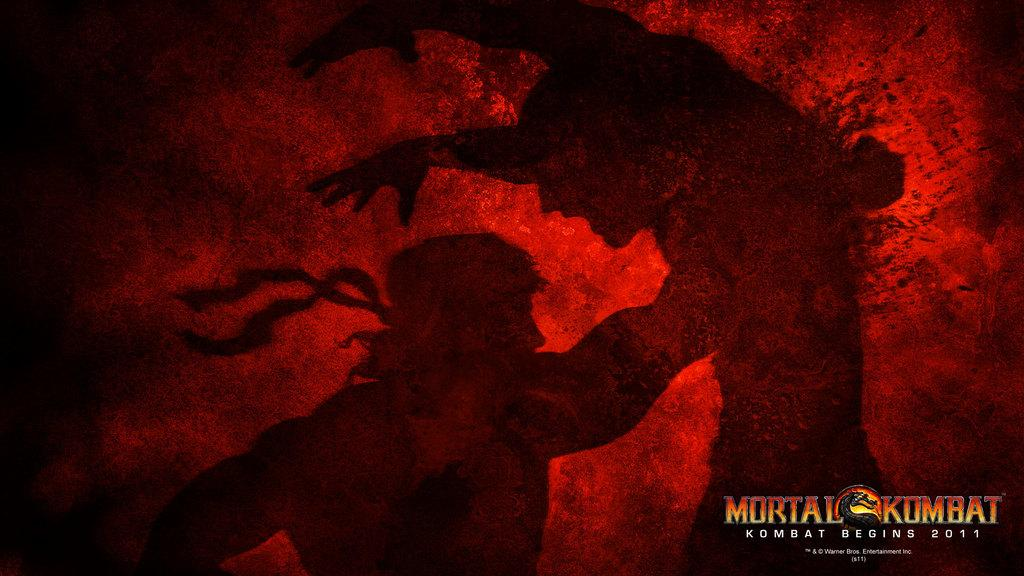<image>
Describe the image concisely. The picture of two men doing karate is an ad for Mortal Kombat. 